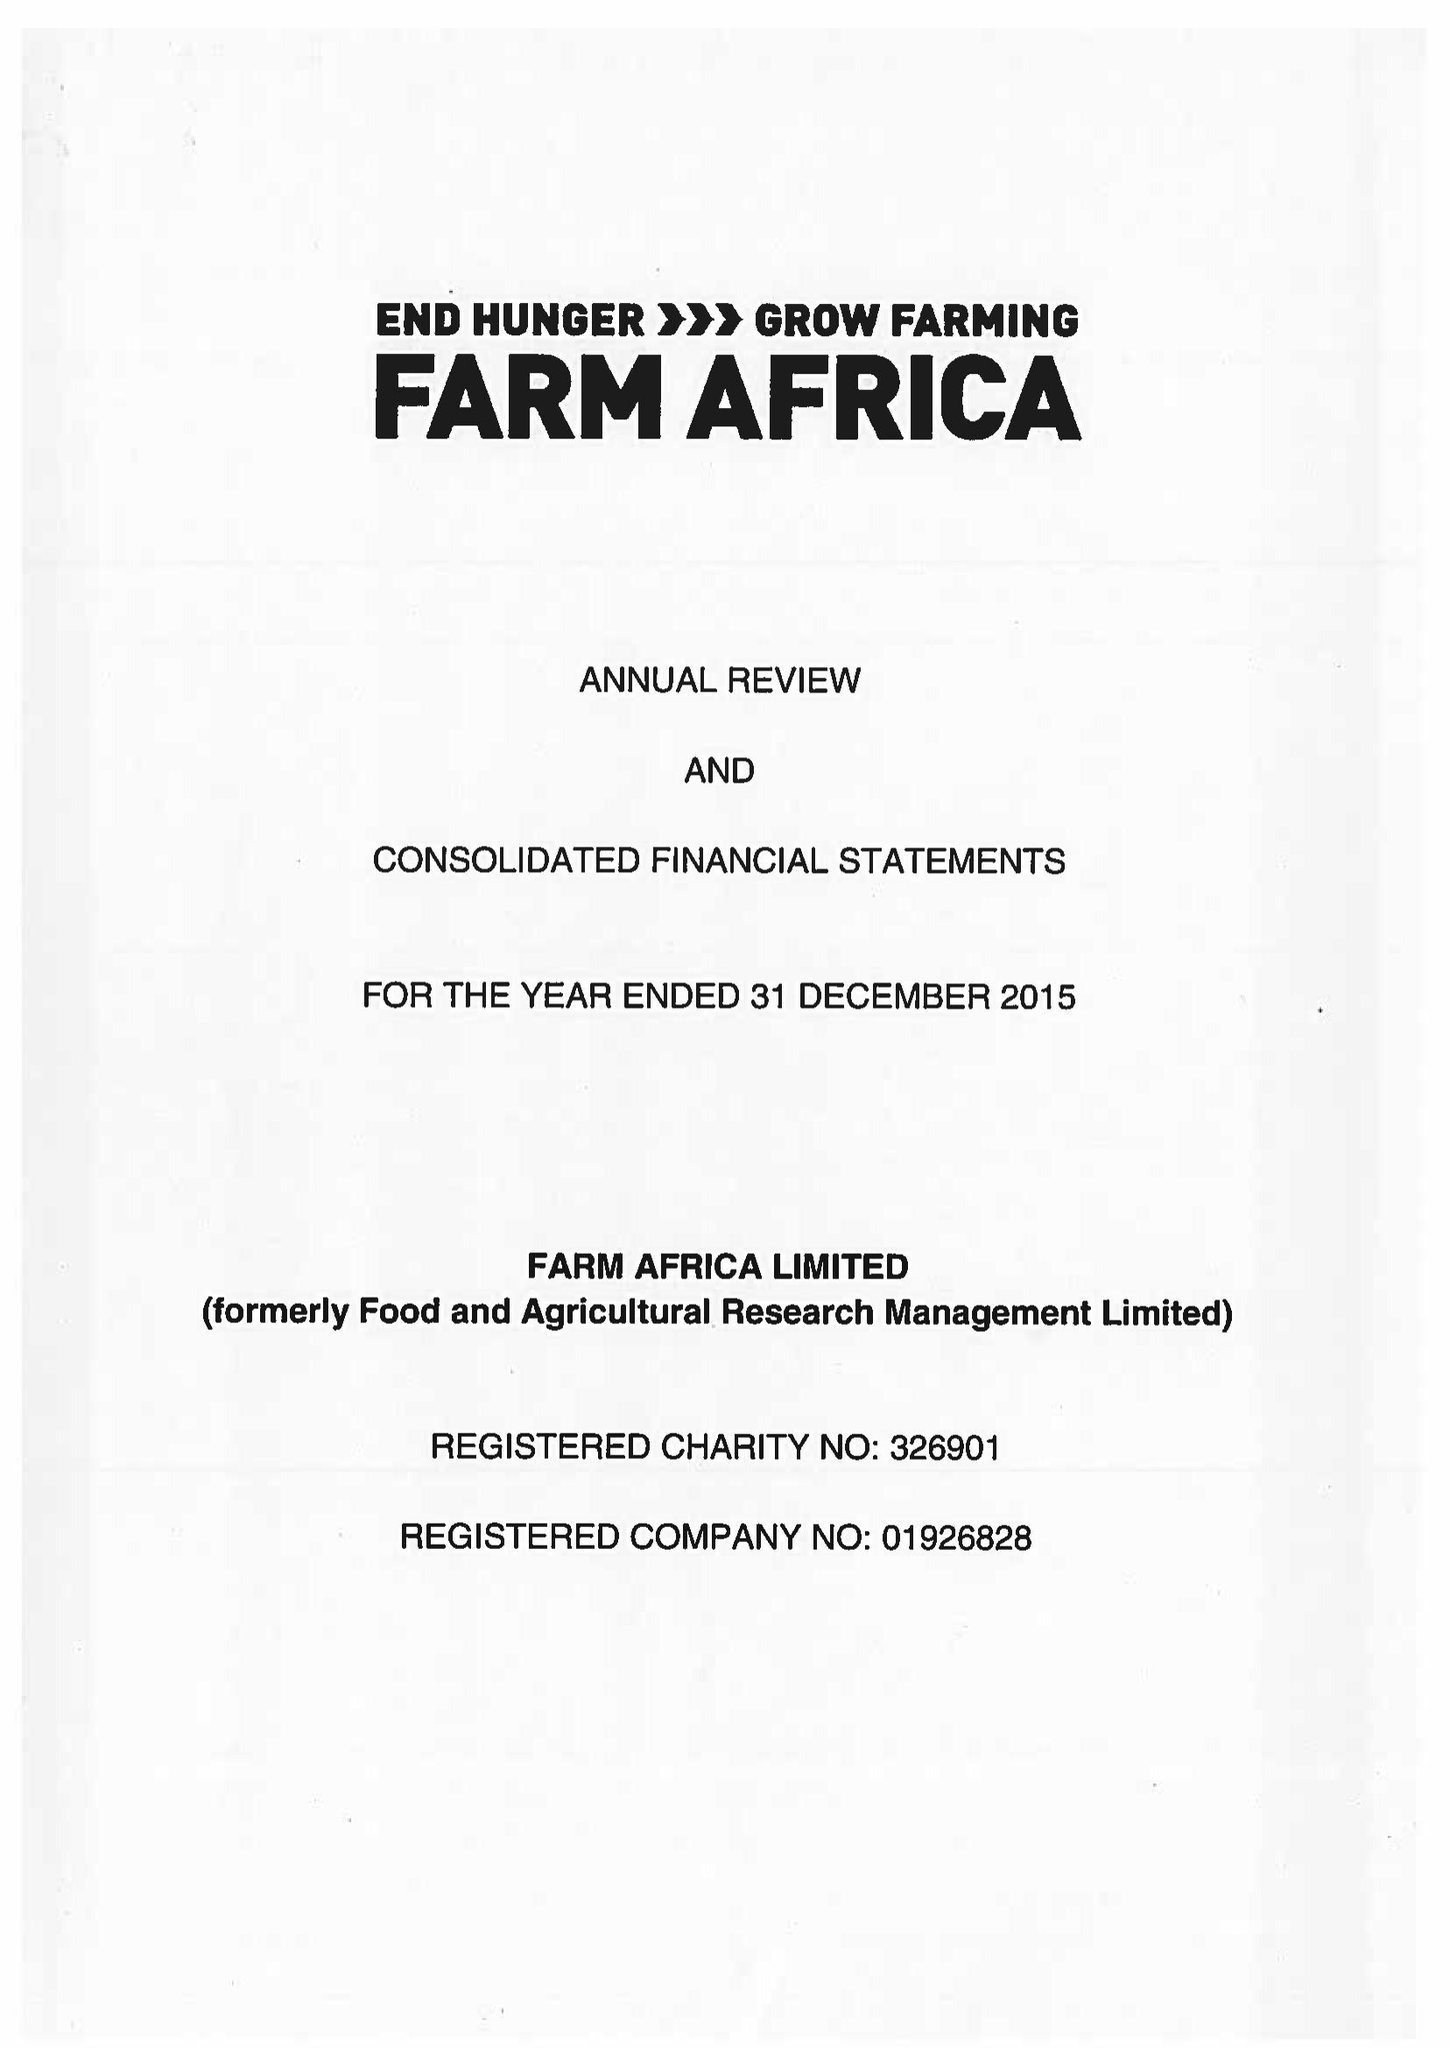What is the value for the charity_name?
Answer the question using a single word or phrase. Farm Africa Ltd. 